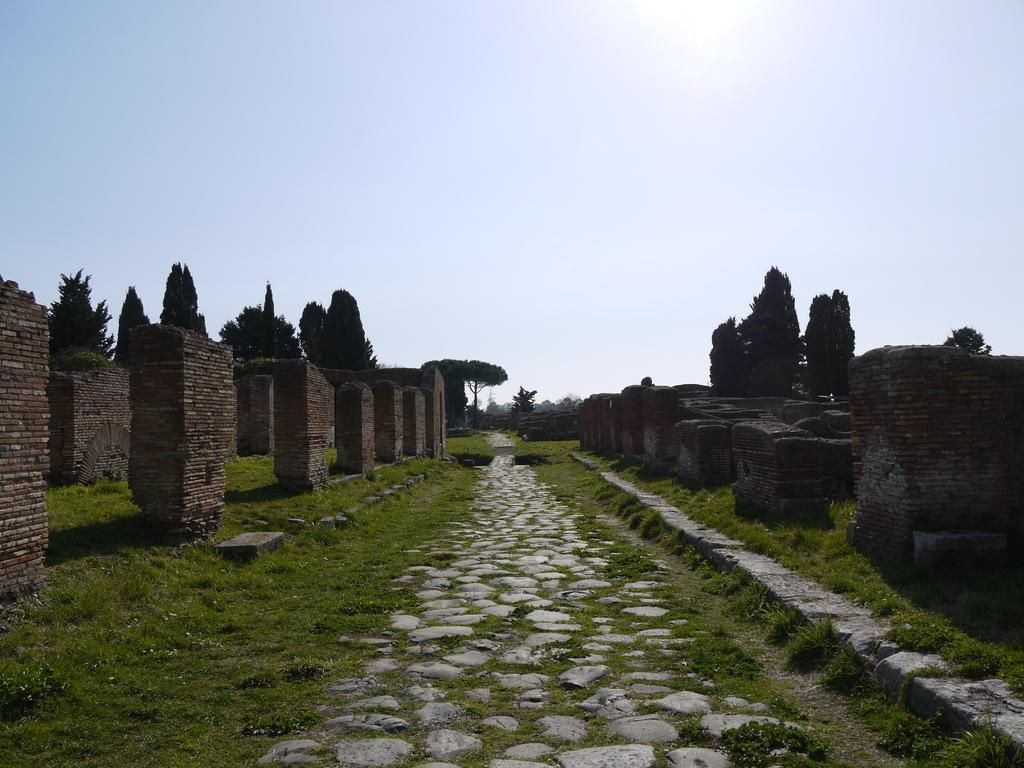What is the main subject of the image? The main subject of the image consists of walls. What type of vegetation is present on the ground? There is green grass on the ground. What can be seen in the middle of the image? There is a path in the middle of the image. What is located on the left and right sides of the image? There are trees on the left and right sides of the image. What is visible at the top of the image? The sky is visible at the top of the image. Can you see any giants playing volleyball in the image? There are no giants or volleyball games present in the image. What type of milk is being served in the image? There is no milk or serving of any kind in the image. 